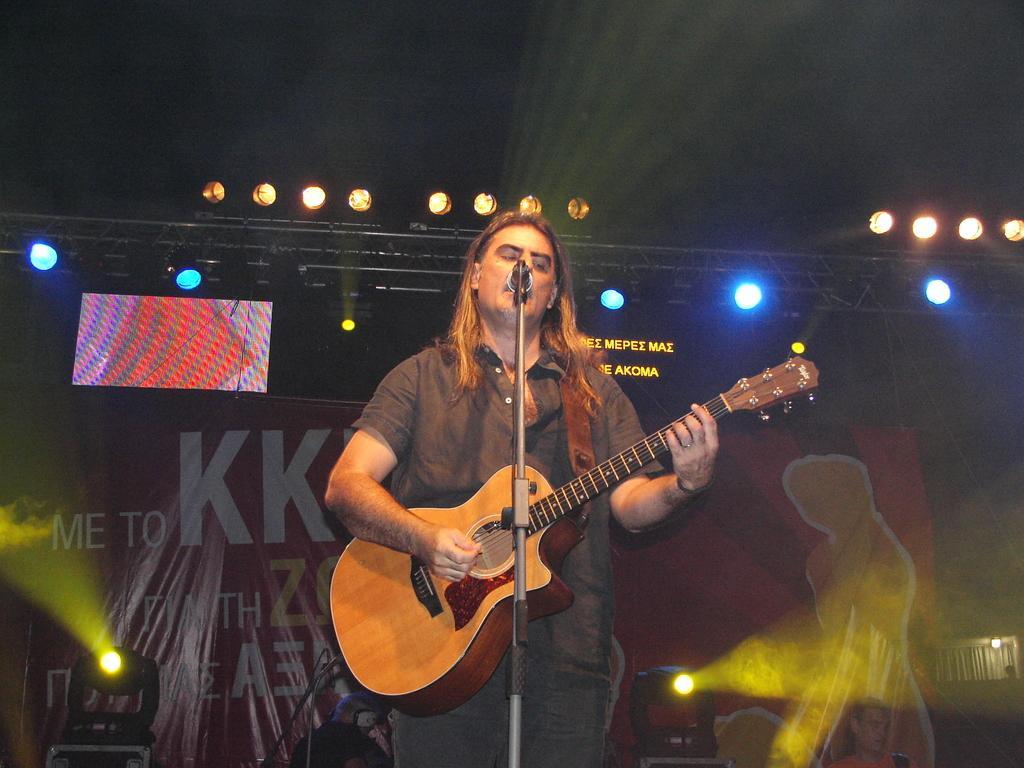Can you describe this image briefly? In this picture there's a man standing, holding a guitar and playing the guitar with his right hand his singing 